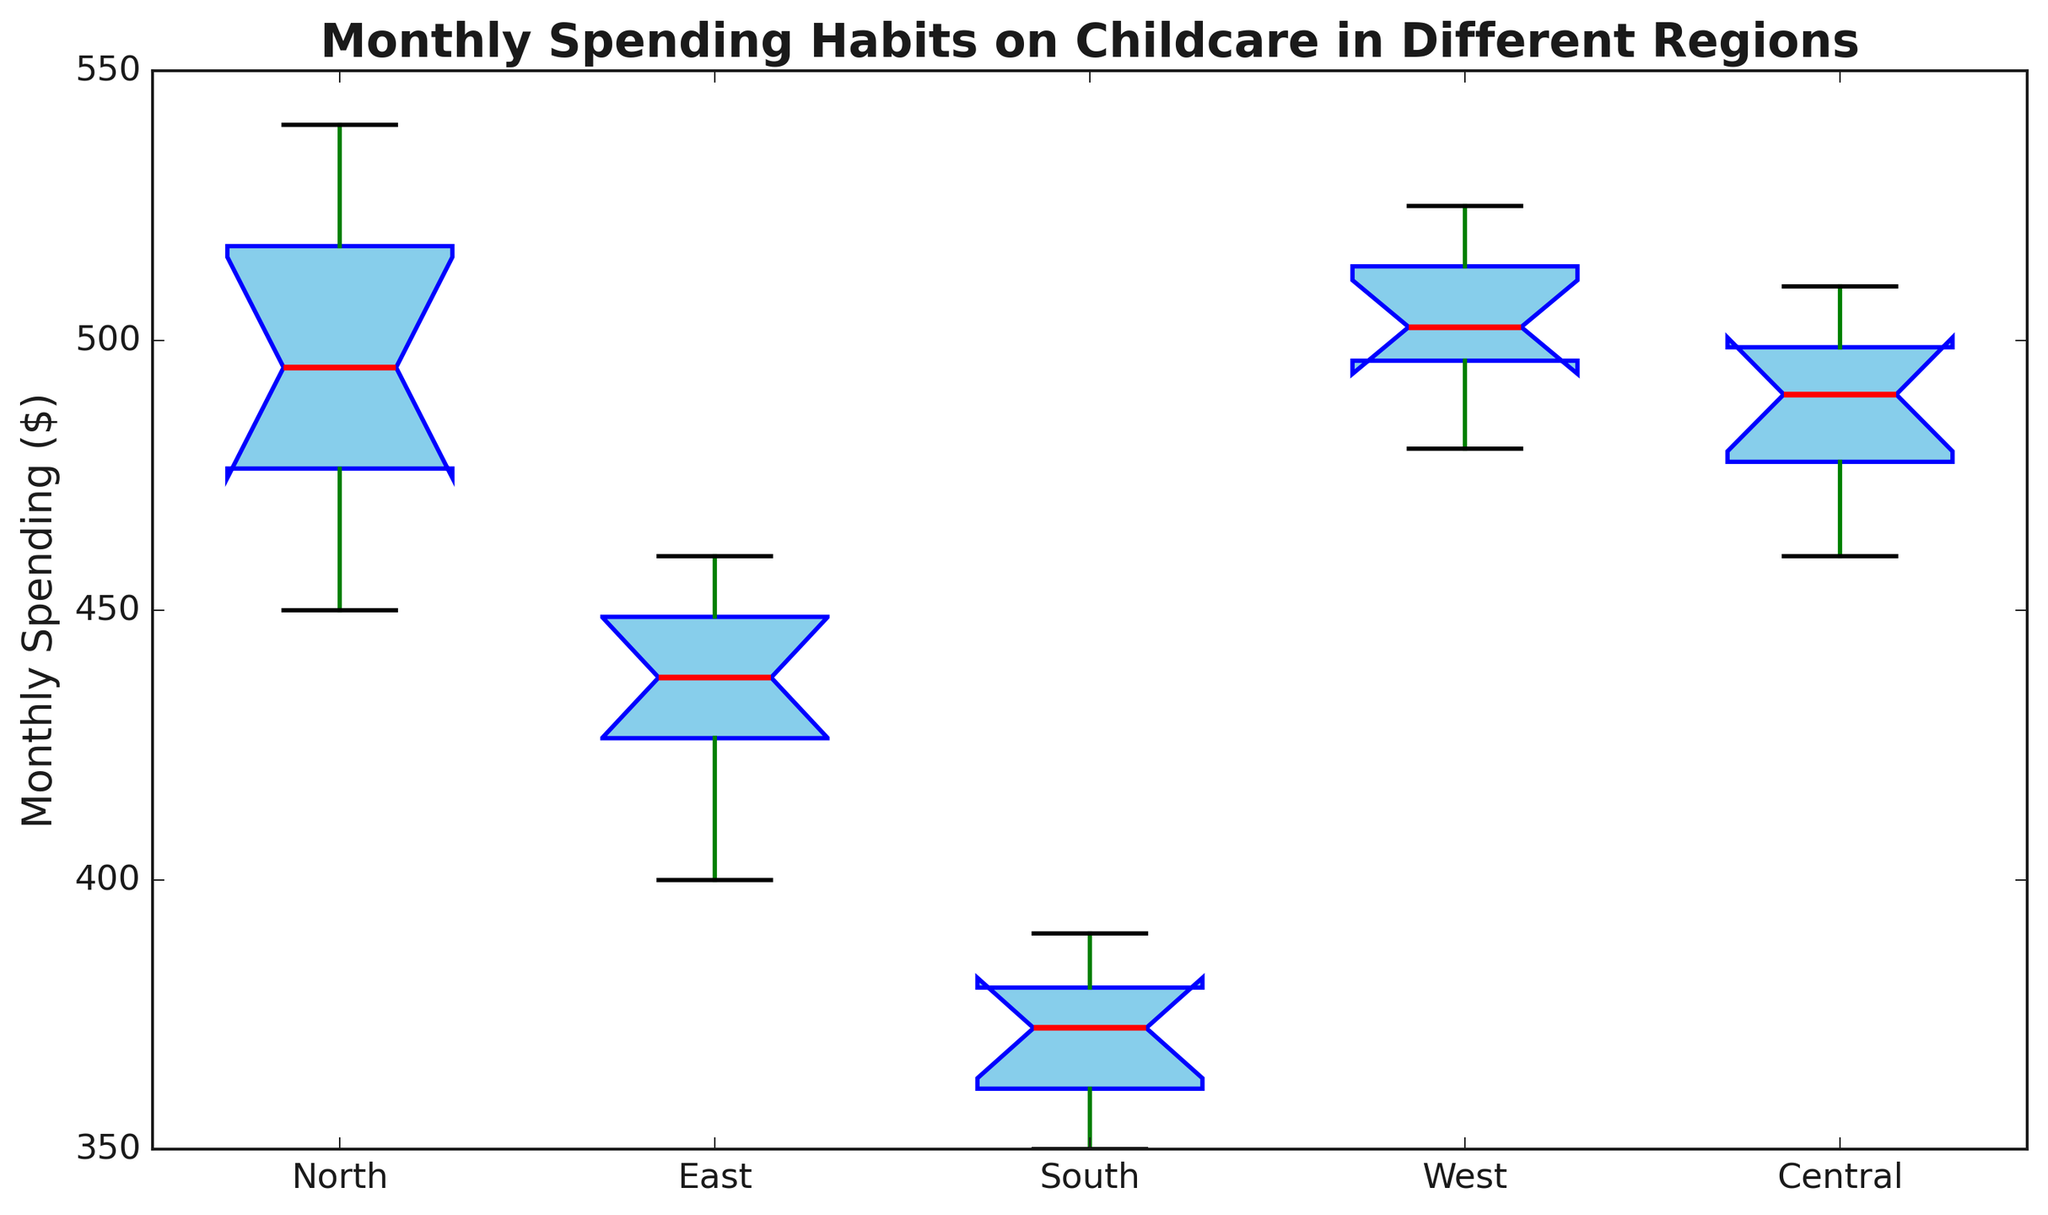What is the median spending on childcare in the North region? To find the median spending, locate the middle value in the sorted dataset of the North region, which is listed in the figure. The median is the middle number in the sequence.
Answer: $490 Which region has the highest median monthly spending on childcare? Look at each box plot's median line (often in red), which represents the median value. The West region has the highest median line.
Answer: West What is the range of monthly spending in the South region? The range is calculated by subtracting the smallest value from the largest value. According to the box plot, the smallest value (bottom whisker) is $350, and the largest value (top whisker) is $390. So, the range is $390 - $350.
Answer: $40 Which region has the smallest interquartile range (IQR) for monthly spending? The IQR is the height of the box in the box plot. The South region has the smallest box, indicating the smallest IQR.
Answer: South Is there any region where the monthly spending exceeds $550? Examine the top whiskers and the fliers (outliers) in each region. None of them exceed $550.
Answer: No Identify the region with the most consistent (least variable) spending on childcare. The most consistent spending is reflected by the smallest spread of the data points (smallest range). The South region has the smallest range ($40) and thus is the most consistent.
Answer: South How does the mean monthly spending compare between the North and Central regions? While the box plot primarily shows the median, the mean often lies near the center of the data distribution. For a more precise comparison of the means, additional calculations would be required, but visually the North and Central regions appear quite similar.
Answer: Similar Which region has the largest outlier in monthly spending? Outliers are typically indicated by points outside the whiskers. The North region has one outlier which is slightly beyond the whisker, around $540.
Answer: North In which region is the median monthly spending closest to the overall average monthly spending? The overall average can be approximated by visually comparing the median lines across all regions. The Central region's median appears closest to a middle value among all regions.
Answer: Central Are there more data points above the median or below the median in the East region? By definition of a median in a box plot, there should be an equal number of data points above and below the median, assuming a symmetric distribution.
Answer: Equal 